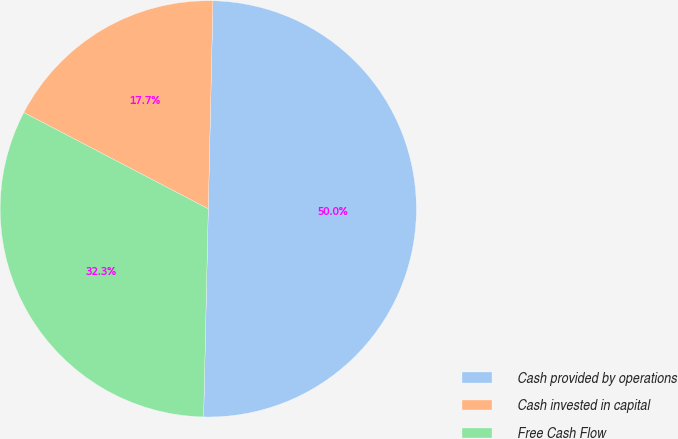Convert chart to OTSL. <chart><loc_0><loc_0><loc_500><loc_500><pie_chart><fcel>Cash provided by operations<fcel>Cash invested in capital<fcel>Free Cash Flow<nl><fcel>50.0%<fcel>17.7%<fcel>32.3%<nl></chart> 